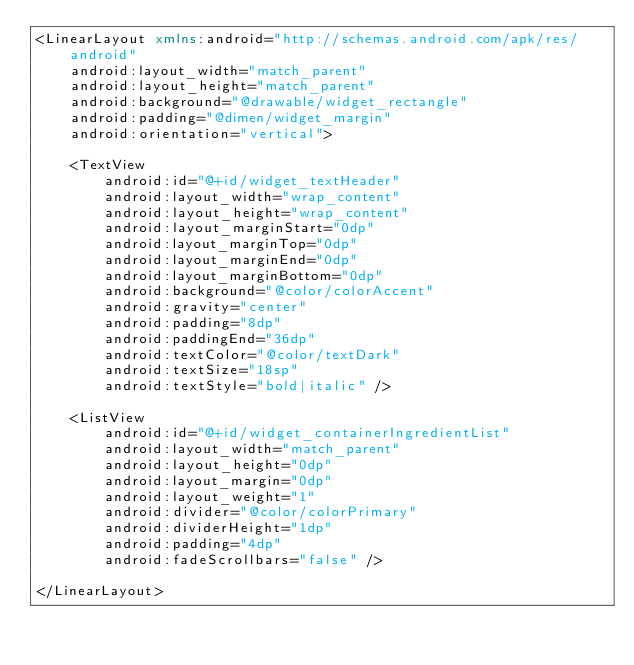Convert code to text. <code><loc_0><loc_0><loc_500><loc_500><_XML_><LinearLayout xmlns:android="http://schemas.android.com/apk/res/android"
    android:layout_width="match_parent"
    android:layout_height="match_parent"
    android:background="@drawable/widget_rectangle"
    android:padding="@dimen/widget_margin"
    android:orientation="vertical">

    <TextView
        android:id="@+id/widget_textHeader"
        android:layout_width="wrap_content"
        android:layout_height="wrap_content"
        android:layout_marginStart="0dp"
        android:layout_marginTop="0dp"
        android:layout_marginEnd="0dp"
        android:layout_marginBottom="0dp"
        android:background="@color/colorAccent"
        android:gravity="center"
        android:padding="8dp"
        android:paddingEnd="36dp"
        android:textColor="@color/textDark"
        android:textSize="18sp"
        android:textStyle="bold|italic" />

    <ListView
        android:id="@+id/widget_containerIngredientList"
        android:layout_width="match_parent"
        android:layout_height="0dp"
        android:layout_margin="0dp"
        android:layout_weight="1"
        android:divider="@color/colorPrimary"
        android:dividerHeight="1dp"
        android:padding="4dp"
        android:fadeScrollbars="false" />

</LinearLayout></code> 